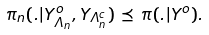Convert formula to latex. <formula><loc_0><loc_0><loc_500><loc_500>\pi _ { n } ( . | Y ^ { o } _ { \Lambda _ { n } } , Y _ { \Lambda _ { n } ^ { c } } ) \, \preceq \, \pi ( . | Y ^ { o } ) .</formula> 